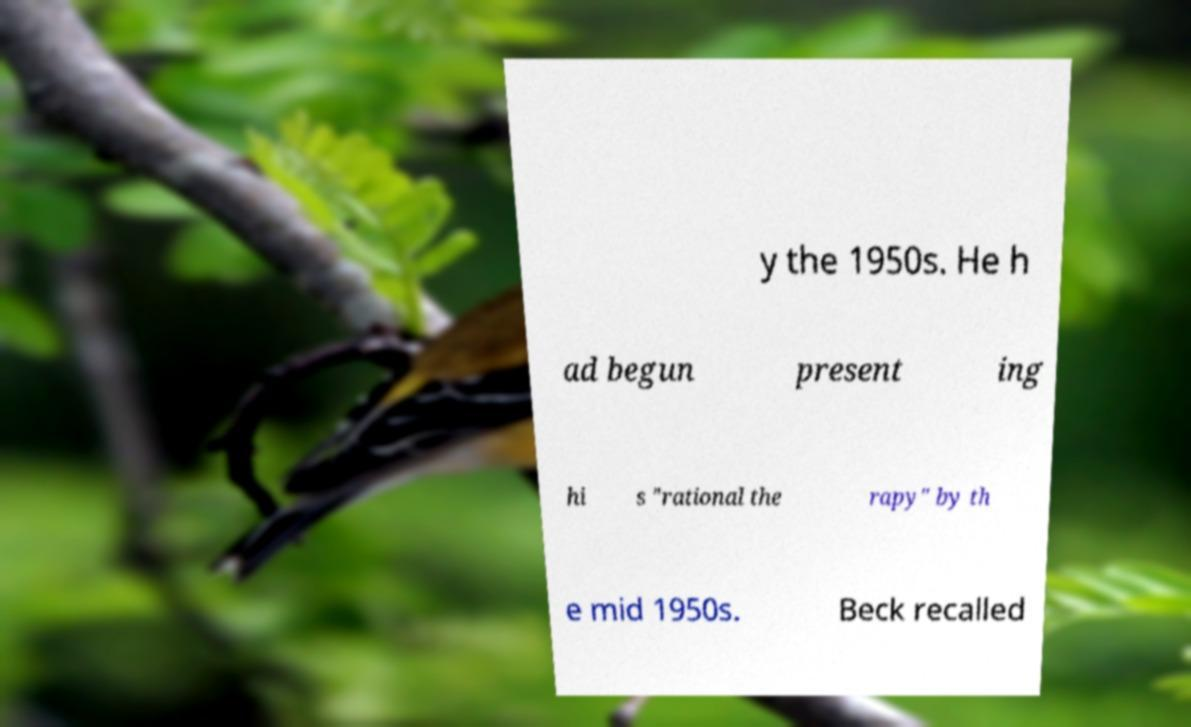I need the written content from this picture converted into text. Can you do that? y the 1950s. He h ad begun present ing hi s "rational the rapy" by th e mid 1950s. Beck recalled 